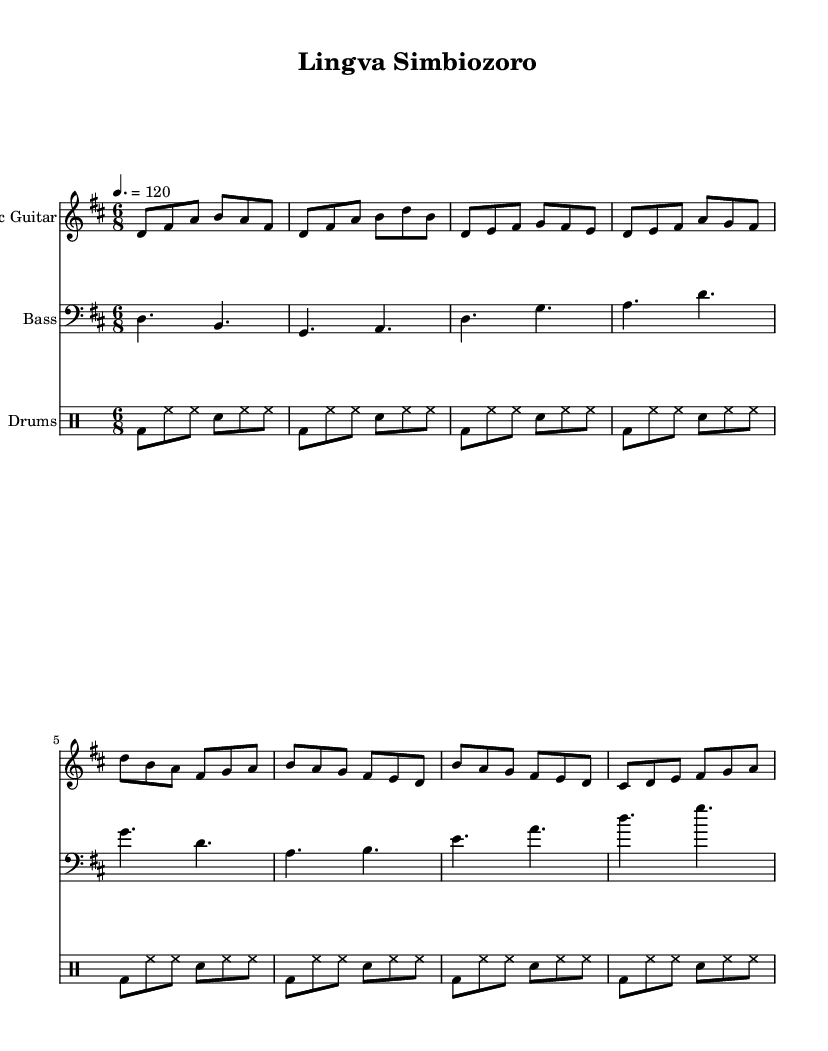What is the key signature of this music? The key signature is D major, which has two sharps (F# and C#). This can be seen at the beginning of the staff where the sharps are indicated.
Answer: D major What is the time signature of this music? The time signature is 6/8, which indicates that there are six eighth notes in each measure. This information is displayed at the start of the score, showing the two numbers stacked.
Answer: 6/8 What is the tempo marking of this piece? The tempo marking is 120 beats per minute, indicated by the text "4. = 120" above the staff. This tells the performer to play at this specific speed.
Answer: 120 How many measures are in the chorus part? The chorus section contains four measures, which can be verified by counting the notated measures in the chorus section of the electric guitar staff.
Answer: 4 What instruments are featured in this score? The instruments featured in this score are Electric Guitar, Bass, and Drums. This is indicated by the instrument names above their respective staves in the score.
Answer: Electric Guitar, Bass, Drums How does the electric guitar's intro compare to the verse? The intro of the electric guitar has a different melodic line than the verse, with specific note sequences starting from D and using a combination of eighth notes. The verse shifts to a different rhythmic pattern and melody.
Answer: Different melodic line 